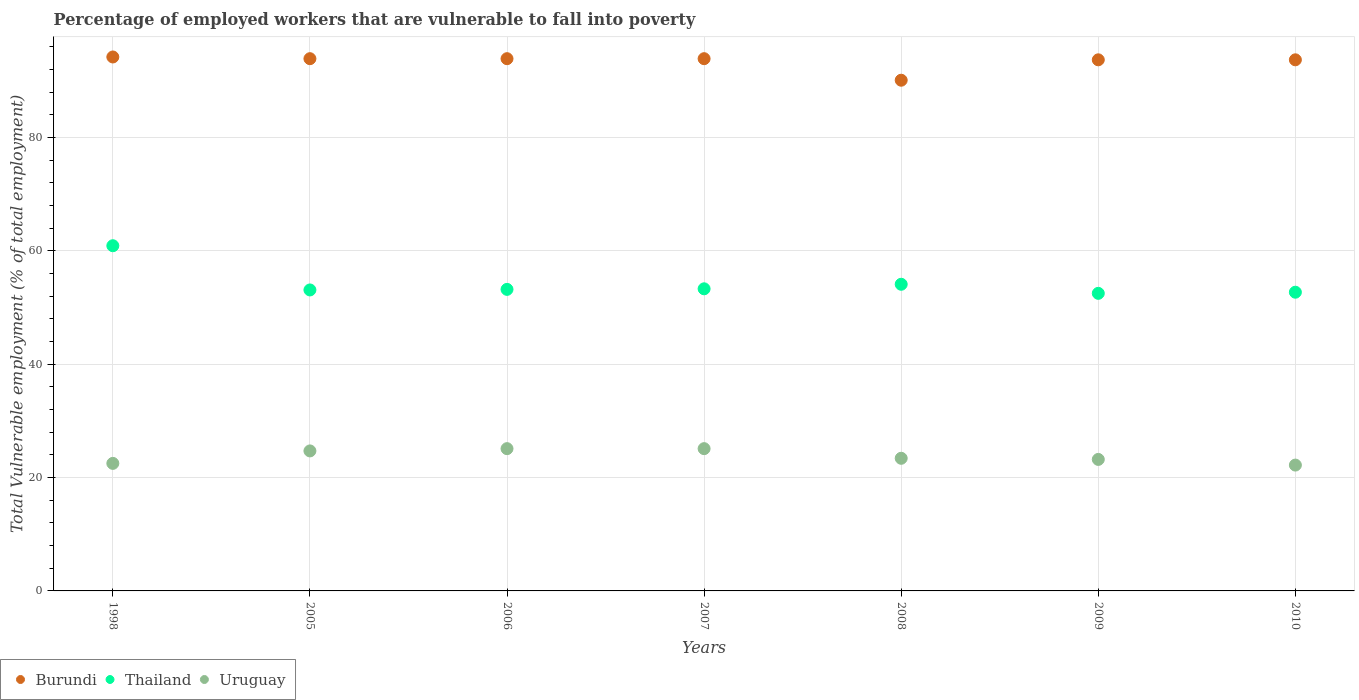Is the number of dotlines equal to the number of legend labels?
Provide a short and direct response. Yes. What is the percentage of employed workers who are vulnerable to fall into poverty in Thailand in 1998?
Your response must be concise. 60.9. Across all years, what is the maximum percentage of employed workers who are vulnerable to fall into poverty in Burundi?
Your answer should be very brief. 94.2. Across all years, what is the minimum percentage of employed workers who are vulnerable to fall into poverty in Burundi?
Offer a very short reply. 90.1. In which year was the percentage of employed workers who are vulnerable to fall into poverty in Uruguay minimum?
Offer a terse response. 2010. What is the total percentage of employed workers who are vulnerable to fall into poverty in Burundi in the graph?
Your answer should be very brief. 653.4. What is the difference between the percentage of employed workers who are vulnerable to fall into poverty in Burundi in 2007 and that in 2010?
Your answer should be compact. 0.2. What is the difference between the percentage of employed workers who are vulnerable to fall into poverty in Burundi in 2008 and the percentage of employed workers who are vulnerable to fall into poverty in Uruguay in 2010?
Give a very brief answer. 67.9. What is the average percentage of employed workers who are vulnerable to fall into poverty in Thailand per year?
Ensure brevity in your answer.  54.26. In the year 2005, what is the difference between the percentage of employed workers who are vulnerable to fall into poverty in Burundi and percentage of employed workers who are vulnerable to fall into poverty in Uruguay?
Give a very brief answer. 69.2. What is the ratio of the percentage of employed workers who are vulnerable to fall into poverty in Uruguay in 2005 to that in 2009?
Ensure brevity in your answer.  1.06. Is the difference between the percentage of employed workers who are vulnerable to fall into poverty in Burundi in 2006 and 2009 greater than the difference between the percentage of employed workers who are vulnerable to fall into poverty in Uruguay in 2006 and 2009?
Your answer should be very brief. No. What is the difference between the highest and the second highest percentage of employed workers who are vulnerable to fall into poverty in Burundi?
Your answer should be compact. 0.3. What is the difference between the highest and the lowest percentage of employed workers who are vulnerable to fall into poverty in Thailand?
Ensure brevity in your answer.  8.4. Does the percentage of employed workers who are vulnerable to fall into poverty in Uruguay monotonically increase over the years?
Provide a short and direct response. No. Is the percentage of employed workers who are vulnerable to fall into poverty in Uruguay strictly less than the percentage of employed workers who are vulnerable to fall into poverty in Burundi over the years?
Your answer should be very brief. Yes. How many dotlines are there?
Make the answer very short. 3. How many years are there in the graph?
Give a very brief answer. 7. What is the difference between two consecutive major ticks on the Y-axis?
Keep it short and to the point. 20. Does the graph contain any zero values?
Offer a terse response. No. Does the graph contain grids?
Make the answer very short. Yes. What is the title of the graph?
Give a very brief answer. Percentage of employed workers that are vulnerable to fall into poverty. Does "France" appear as one of the legend labels in the graph?
Offer a terse response. No. What is the label or title of the X-axis?
Make the answer very short. Years. What is the label or title of the Y-axis?
Make the answer very short. Total Vulnerable employment (% of total employment). What is the Total Vulnerable employment (% of total employment) in Burundi in 1998?
Give a very brief answer. 94.2. What is the Total Vulnerable employment (% of total employment) in Thailand in 1998?
Provide a short and direct response. 60.9. What is the Total Vulnerable employment (% of total employment) of Uruguay in 1998?
Make the answer very short. 22.5. What is the Total Vulnerable employment (% of total employment) in Burundi in 2005?
Provide a succinct answer. 93.9. What is the Total Vulnerable employment (% of total employment) in Thailand in 2005?
Provide a short and direct response. 53.1. What is the Total Vulnerable employment (% of total employment) in Uruguay in 2005?
Ensure brevity in your answer.  24.7. What is the Total Vulnerable employment (% of total employment) of Burundi in 2006?
Your answer should be compact. 93.9. What is the Total Vulnerable employment (% of total employment) of Thailand in 2006?
Provide a succinct answer. 53.2. What is the Total Vulnerable employment (% of total employment) in Uruguay in 2006?
Keep it short and to the point. 25.1. What is the Total Vulnerable employment (% of total employment) of Burundi in 2007?
Your response must be concise. 93.9. What is the Total Vulnerable employment (% of total employment) in Thailand in 2007?
Provide a short and direct response. 53.3. What is the Total Vulnerable employment (% of total employment) of Uruguay in 2007?
Make the answer very short. 25.1. What is the Total Vulnerable employment (% of total employment) in Burundi in 2008?
Provide a succinct answer. 90.1. What is the Total Vulnerable employment (% of total employment) of Thailand in 2008?
Keep it short and to the point. 54.1. What is the Total Vulnerable employment (% of total employment) in Uruguay in 2008?
Give a very brief answer. 23.4. What is the Total Vulnerable employment (% of total employment) in Burundi in 2009?
Your answer should be compact. 93.7. What is the Total Vulnerable employment (% of total employment) of Thailand in 2009?
Your answer should be very brief. 52.5. What is the Total Vulnerable employment (% of total employment) of Uruguay in 2009?
Your answer should be very brief. 23.2. What is the Total Vulnerable employment (% of total employment) of Burundi in 2010?
Your response must be concise. 93.7. What is the Total Vulnerable employment (% of total employment) in Thailand in 2010?
Your response must be concise. 52.7. What is the Total Vulnerable employment (% of total employment) in Uruguay in 2010?
Offer a terse response. 22.2. Across all years, what is the maximum Total Vulnerable employment (% of total employment) in Burundi?
Give a very brief answer. 94.2. Across all years, what is the maximum Total Vulnerable employment (% of total employment) of Thailand?
Make the answer very short. 60.9. Across all years, what is the maximum Total Vulnerable employment (% of total employment) of Uruguay?
Your response must be concise. 25.1. Across all years, what is the minimum Total Vulnerable employment (% of total employment) in Burundi?
Provide a short and direct response. 90.1. Across all years, what is the minimum Total Vulnerable employment (% of total employment) in Thailand?
Make the answer very short. 52.5. Across all years, what is the minimum Total Vulnerable employment (% of total employment) in Uruguay?
Make the answer very short. 22.2. What is the total Total Vulnerable employment (% of total employment) in Burundi in the graph?
Ensure brevity in your answer.  653.4. What is the total Total Vulnerable employment (% of total employment) in Thailand in the graph?
Your answer should be compact. 379.8. What is the total Total Vulnerable employment (% of total employment) of Uruguay in the graph?
Offer a terse response. 166.2. What is the difference between the Total Vulnerable employment (% of total employment) of Burundi in 1998 and that in 2005?
Give a very brief answer. 0.3. What is the difference between the Total Vulnerable employment (% of total employment) of Thailand in 1998 and that in 2005?
Provide a succinct answer. 7.8. What is the difference between the Total Vulnerable employment (% of total employment) in Thailand in 1998 and that in 2006?
Your response must be concise. 7.7. What is the difference between the Total Vulnerable employment (% of total employment) of Burundi in 1998 and that in 2007?
Make the answer very short. 0.3. What is the difference between the Total Vulnerable employment (% of total employment) of Thailand in 1998 and that in 2007?
Give a very brief answer. 7.6. What is the difference between the Total Vulnerable employment (% of total employment) in Uruguay in 1998 and that in 2007?
Provide a succinct answer. -2.6. What is the difference between the Total Vulnerable employment (% of total employment) of Uruguay in 1998 and that in 2008?
Offer a very short reply. -0.9. What is the difference between the Total Vulnerable employment (% of total employment) in Burundi in 1998 and that in 2009?
Your response must be concise. 0.5. What is the difference between the Total Vulnerable employment (% of total employment) in Thailand in 1998 and that in 2009?
Provide a succinct answer. 8.4. What is the difference between the Total Vulnerable employment (% of total employment) of Burundi in 1998 and that in 2010?
Keep it short and to the point. 0.5. What is the difference between the Total Vulnerable employment (% of total employment) in Burundi in 2005 and that in 2006?
Give a very brief answer. 0. What is the difference between the Total Vulnerable employment (% of total employment) of Thailand in 2005 and that in 2006?
Keep it short and to the point. -0.1. What is the difference between the Total Vulnerable employment (% of total employment) of Thailand in 2005 and that in 2007?
Offer a terse response. -0.2. What is the difference between the Total Vulnerable employment (% of total employment) in Thailand in 2005 and that in 2008?
Your response must be concise. -1. What is the difference between the Total Vulnerable employment (% of total employment) of Burundi in 2005 and that in 2009?
Ensure brevity in your answer.  0.2. What is the difference between the Total Vulnerable employment (% of total employment) of Uruguay in 2005 and that in 2009?
Provide a succinct answer. 1.5. What is the difference between the Total Vulnerable employment (% of total employment) of Uruguay in 2005 and that in 2010?
Provide a short and direct response. 2.5. What is the difference between the Total Vulnerable employment (% of total employment) of Burundi in 2006 and that in 2007?
Your answer should be very brief. 0. What is the difference between the Total Vulnerable employment (% of total employment) in Thailand in 2006 and that in 2007?
Your response must be concise. -0.1. What is the difference between the Total Vulnerable employment (% of total employment) in Uruguay in 2006 and that in 2007?
Provide a short and direct response. 0. What is the difference between the Total Vulnerable employment (% of total employment) in Burundi in 2006 and that in 2008?
Offer a very short reply. 3.8. What is the difference between the Total Vulnerable employment (% of total employment) of Burundi in 2006 and that in 2009?
Give a very brief answer. 0.2. What is the difference between the Total Vulnerable employment (% of total employment) of Burundi in 2006 and that in 2010?
Offer a very short reply. 0.2. What is the difference between the Total Vulnerable employment (% of total employment) of Thailand in 2006 and that in 2010?
Your response must be concise. 0.5. What is the difference between the Total Vulnerable employment (% of total employment) of Thailand in 2007 and that in 2008?
Make the answer very short. -0.8. What is the difference between the Total Vulnerable employment (% of total employment) in Uruguay in 2007 and that in 2008?
Your answer should be compact. 1.7. What is the difference between the Total Vulnerable employment (% of total employment) in Burundi in 2007 and that in 2009?
Your response must be concise. 0.2. What is the difference between the Total Vulnerable employment (% of total employment) of Uruguay in 2007 and that in 2009?
Your response must be concise. 1.9. What is the difference between the Total Vulnerable employment (% of total employment) in Burundi in 2007 and that in 2010?
Your answer should be compact. 0.2. What is the difference between the Total Vulnerable employment (% of total employment) of Uruguay in 2007 and that in 2010?
Offer a terse response. 2.9. What is the difference between the Total Vulnerable employment (% of total employment) in Burundi in 2008 and that in 2009?
Your response must be concise. -3.6. What is the difference between the Total Vulnerable employment (% of total employment) in Uruguay in 2008 and that in 2009?
Your response must be concise. 0.2. What is the difference between the Total Vulnerable employment (% of total employment) of Burundi in 2008 and that in 2010?
Keep it short and to the point. -3.6. What is the difference between the Total Vulnerable employment (% of total employment) of Thailand in 2009 and that in 2010?
Your answer should be very brief. -0.2. What is the difference between the Total Vulnerable employment (% of total employment) in Burundi in 1998 and the Total Vulnerable employment (% of total employment) in Thailand in 2005?
Provide a succinct answer. 41.1. What is the difference between the Total Vulnerable employment (% of total employment) of Burundi in 1998 and the Total Vulnerable employment (% of total employment) of Uruguay in 2005?
Your response must be concise. 69.5. What is the difference between the Total Vulnerable employment (% of total employment) in Thailand in 1998 and the Total Vulnerable employment (% of total employment) in Uruguay in 2005?
Keep it short and to the point. 36.2. What is the difference between the Total Vulnerable employment (% of total employment) in Burundi in 1998 and the Total Vulnerable employment (% of total employment) in Uruguay in 2006?
Make the answer very short. 69.1. What is the difference between the Total Vulnerable employment (% of total employment) of Thailand in 1998 and the Total Vulnerable employment (% of total employment) of Uruguay in 2006?
Your response must be concise. 35.8. What is the difference between the Total Vulnerable employment (% of total employment) in Burundi in 1998 and the Total Vulnerable employment (% of total employment) in Thailand in 2007?
Provide a short and direct response. 40.9. What is the difference between the Total Vulnerable employment (% of total employment) of Burundi in 1998 and the Total Vulnerable employment (% of total employment) of Uruguay in 2007?
Ensure brevity in your answer.  69.1. What is the difference between the Total Vulnerable employment (% of total employment) in Thailand in 1998 and the Total Vulnerable employment (% of total employment) in Uruguay in 2007?
Make the answer very short. 35.8. What is the difference between the Total Vulnerable employment (% of total employment) in Burundi in 1998 and the Total Vulnerable employment (% of total employment) in Thailand in 2008?
Provide a short and direct response. 40.1. What is the difference between the Total Vulnerable employment (% of total employment) in Burundi in 1998 and the Total Vulnerable employment (% of total employment) in Uruguay in 2008?
Keep it short and to the point. 70.8. What is the difference between the Total Vulnerable employment (% of total employment) of Thailand in 1998 and the Total Vulnerable employment (% of total employment) of Uruguay in 2008?
Give a very brief answer. 37.5. What is the difference between the Total Vulnerable employment (% of total employment) of Burundi in 1998 and the Total Vulnerable employment (% of total employment) of Thailand in 2009?
Give a very brief answer. 41.7. What is the difference between the Total Vulnerable employment (% of total employment) of Burundi in 1998 and the Total Vulnerable employment (% of total employment) of Uruguay in 2009?
Make the answer very short. 71. What is the difference between the Total Vulnerable employment (% of total employment) in Thailand in 1998 and the Total Vulnerable employment (% of total employment) in Uruguay in 2009?
Your answer should be very brief. 37.7. What is the difference between the Total Vulnerable employment (% of total employment) of Burundi in 1998 and the Total Vulnerable employment (% of total employment) of Thailand in 2010?
Your answer should be very brief. 41.5. What is the difference between the Total Vulnerable employment (% of total employment) in Thailand in 1998 and the Total Vulnerable employment (% of total employment) in Uruguay in 2010?
Your answer should be compact. 38.7. What is the difference between the Total Vulnerable employment (% of total employment) in Burundi in 2005 and the Total Vulnerable employment (% of total employment) in Thailand in 2006?
Give a very brief answer. 40.7. What is the difference between the Total Vulnerable employment (% of total employment) in Burundi in 2005 and the Total Vulnerable employment (% of total employment) in Uruguay in 2006?
Your response must be concise. 68.8. What is the difference between the Total Vulnerable employment (% of total employment) in Thailand in 2005 and the Total Vulnerable employment (% of total employment) in Uruguay in 2006?
Ensure brevity in your answer.  28. What is the difference between the Total Vulnerable employment (% of total employment) in Burundi in 2005 and the Total Vulnerable employment (% of total employment) in Thailand in 2007?
Provide a short and direct response. 40.6. What is the difference between the Total Vulnerable employment (% of total employment) in Burundi in 2005 and the Total Vulnerable employment (% of total employment) in Uruguay in 2007?
Provide a short and direct response. 68.8. What is the difference between the Total Vulnerable employment (% of total employment) of Burundi in 2005 and the Total Vulnerable employment (% of total employment) of Thailand in 2008?
Your answer should be compact. 39.8. What is the difference between the Total Vulnerable employment (% of total employment) of Burundi in 2005 and the Total Vulnerable employment (% of total employment) of Uruguay in 2008?
Provide a succinct answer. 70.5. What is the difference between the Total Vulnerable employment (% of total employment) of Thailand in 2005 and the Total Vulnerable employment (% of total employment) of Uruguay in 2008?
Your answer should be very brief. 29.7. What is the difference between the Total Vulnerable employment (% of total employment) of Burundi in 2005 and the Total Vulnerable employment (% of total employment) of Thailand in 2009?
Your answer should be compact. 41.4. What is the difference between the Total Vulnerable employment (% of total employment) in Burundi in 2005 and the Total Vulnerable employment (% of total employment) in Uruguay in 2009?
Make the answer very short. 70.7. What is the difference between the Total Vulnerable employment (% of total employment) in Thailand in 2005 and the Total Vulnerable employment (% of total employment) in Uruguay in 2009?
Provide a short and direct response. 29.9. What is the difference between the Total Vulnerable employment (% of total employment) of Burundi in 2005 and the Total Vulnerable employment (% of total employment) of Thailand in 2010?
Give a very brief answer. 41.2. What is the difference between the Total Vulnerable employment (% of total employment) of Burundi in 2005 and the Total Vulnerable employment (% of total employment) of Uruguay in 2010?
Offer a very short reply. 71.7. What is the difference between the Total Vulnerable employment (% of total employment) in Thailand in 2005 and the Total Vulnerable employment (% of total employment) in Uruguay in 2010?
Provide a short and direct response. 30.9. What is the difference between the Total Vulnerable employment (% of total employment) of Burundi in 2006 and the Total Vulnerable employment (% of total employment) of Thailand in 2007?
Make the answer very short. 40.6. What is the difference between the Total Vulnerable employment (% of total employment) of Burundi in 2006 and the Total Vulnerable employment (% of total employment) of Uruguay in 2007?
Offer a terse response. 68.8. What is the difference between the Total Vulnerable employment (% of total employment) in Thailand in 2006 and the Total Vulnerable employment (% of total employment) in Uruguay in 2007?
Your answer should be very brief. 28.1. What is the difference between the Total Vulnerable employment (% of total employment) of Burundi in 2006 and the Total Vulnerable employment (% of total employment) of Thailand in 2008?
Your answer should be compact. 39.8. What is the difference between the Total Vulnerable employment (% of total employment) of Burundi in 2006 and the Total Vulnerable employment (% of total employment) of Uruguay in 2008?
Your response must be concise. 70.5. What is the difference between the Total Vulnerable employment (% of total employment) in Thailand in 2006 and the Total Vulnerable employment (% of total employment) in Uruguay in 2008?
Give a very brief answer. 29.8. What is the difference between the Total Vulnerable employment (% of total employment) of Burundi in 2006 and the Total Vulnerable employment (% of total employment) of Thailand in 2009?
Offer a very short reply. 41.4. What is the difference between the Total Vulnerable employment (% of total employment) in Burundi in 2006 and the Total Vulnerable employment (% of total employment) in Uruguay in 2009?
Your response must be concise. 70.7. What is the difference between the Total Vulnerable employment (% of total employment) in Thailand in 2006 and the Total Vulnerable employment (% of total employment) in Uruguay in 2009?
Your answer should be compact. 30. What is the difference between the Total Vulnerable employment (% of total employment) of Burundi in 2006 and the Total Vulnerable employment (% of total employment) of Thailand in 2010?
Provide a succinct answer. 41.2. What is the difference between the Total Vulnerable employment (% of total employment) of Burundi in 2006 and the Total Vulnerable employment (% of total employment) of Uruguay in 2010?
Your answer should be compact. 71.7. What is the difference between the Total Vulnerable employment (% of total employment) of Thailand in 2006 and the Total Vulnerable employment (% of total employment) of Uruguay in 2010?
Ensure brevity in your answer.  31. What is the difference between the Total Vulnerable employment (% of total employment) in Burundi in 2007 and the Total Vulnerable employment (% of total employment) in Thailand in 2008?
Give a very brief answer. 39.8. What is the difference between the Total Vulnerable employment (% of total employment) of Burundi in 2007 and the Total Vulnerable employment (% of total employment) of Uruguay in 2008?
Your answer should be very brief. 70.5. What is the difference between the Total Vulnerable employment (% of total employment) in Thailand in 2007 and the Total Vulnerable employment (% of total employment) in Uruguay in 2008?
Provide a succinct answer. 29.9. What is the difference between the Total Vulnerable employment (% of total employment) of Burundi in 2007 and the Total Vulnerable employment (% of total employment) of Thailand in 2009?
Provide a succinct answer. 41.4. What is the difference between the Total Vulnerable employment (% of total employment) of Burundi in 2007 and the Total Vulnerable employment (% of total employment) of Uruguay in 2009?
Offer a very short reply. 70.7. What is the difference between the Total Vulnerable employment (% of total employment) in Thailand in 2007 and the Total Vulnerable employment (% of total employment) in Uruguay in 2009?
Provide a short and direct response. 30.1. What is the difference between the Total Vulnerable employment (% of total employment) in Burundi in 2007 and the Total Vulnerable employment (% of total employment) in Thailand in 2010?
Ensure brevity in your answer.  41.2. What is the difference between the Total Vulnerable employment (% of total employment) of Burundi in 2007 and the Total Vulnerable employment (% of total employment) of Uruguay in 2010?
Provide a succinct answer. 71.7. What is the difference between the Total Vulnerable employment (% of total employment) in Thailand in 2007 and the Total Vulnerable employment (% of total employment) in Uruguay in 2010?
Keep it short and to the point. 31.1. What is the difference between the Total Vulnerable employment (% of total employment) in Burundi in 2008 and the Total Vulnerable employment (% of total employment) in Thailand in 2009?
Make the answer very short. 37.6. What is the difference between the Total Vulnerable employment (% of total employment) in Burundi in 2008 and the Total Vulnerable employment (% of total employment) in Uruguay in 2009?
Offer a terse response. 66.9. What is the difference between the Total Vulnerable employment (% of total employment) in Thailand in 2008 and the Total Vulnerable employment (% of total employment) in Uruguay in 2009?
Keep it short and to the point. 30.9. What is the difference between the Total Vulnerable employment (% of total employment) of Burundi in 2008 and the Total Vulnerable employment (% of total employment) of Thailand in 2010?
Your response must be concise. 37.4. What is the difference between the Total Vulnerable employment (% of total employment) in Burundi in 2008 and the Total Vulnerable employment (% of total employment) in Uruguay in 2010?
Your answer should be very brief. 67.9. What is the difference between the Total Vulnerable employment (% of total employment) in Thailand in 2008 and the Total Vulnerable employment (% of total employment) in Uruguay in 2010?
Provide a short and direct response. 31.9. What is the difference between the Total Vulnerable employment (% of total employment) of Burundi in 2009 and the Total Vulnerable employment (% of total employment) of Uruguay in 2010?
Keep it short and to the point. 71.5. What is the difference between the Total Vulnerable employment (% of total employment) of Thailand in 2009 and the Total Vulnerable employment (% of total employment) of Uruguay in 2010?
Keep it short and to the point. 30.3. What is the average Total Vulnerable employment (% of total employment) in Burundi per year?
Give a very brief answer. 93.34. What is the average Total Vulnerable employment (% of total employment) in Thailand per year?
Offer a terse response. 54.26. What is the average Total Vulnerable employment (% of total employment) of Uruguay per year?
Offer a terse response. 23.74. In the year 1998, what is the difference between the Total Vulnerable employment (% of total employment) of Burundi and Total Vulnerable employment (% of total employment) of Thailand?
Keep it short and to the point. 33.3. In the year 1998, what is the difference between the Total Vulnerable employment (% of total employment) of Burundi and Total Vulnerable employment (% of total employment) of Uruguay?
Your answer should be compact. 71.7. In the year 1998, what is the difference between the Total Vulnerable employment (% of total employment) of Thailand and Total Vulnerable employment (% of total employment) of Uruguay?
Provide a short and direct response. 38.4. In the year 2005, what is the difference between the Total Vulnerable employment (% of total employment) in Burundi and Total Vulnerable employment (% of total employment) in Thailand?
Your answer should be compact. 40.8. In the year 2005, what is the difference between the Total Vulnerable employment (% of total employment) of Burundi and Total Vulnerable employment (% of total employment) of Uruguay?
Provide a short and direct response. 69.2. In the year 2005, what is the difference between the Total Vulnerable employment (% of total employment) of Thailand and Total Vulnerable employment (% of total employment) of Uruguay?
Keep it short and to the point. 28.4. In the year 2006, what is the difference between the Total Vulnerable employment (% of total employment) of Burundi and Total Vulnerable employment (% of total employment) of Thailand?
Ensure brevity in your answer.  40.7. In the year 2006, what is the difference between the Total Vulnerable employment (% of total employment) in Burundi and Total Vulnerable employment (% of total employment) in Uruguay?
Ensure brevity in your answer.  68.8. In the year 2006, what is the difference between the Total Vulnerable employment (% of total employment) in Thailand and Total Vulnerable employment (% of total employment) in Uruguay?
Offer a very short reply. 28.1. In the year 2007, what is the difference between the Total Vulnerable employment (% of total employment) in Burundi and Total Vulnerable employment (% of total employment) in Thailand?
Your response must be concise. 40.6. In the year 2007, what is the difference between the Total Vulnerable employment (% of total employment) in Burundi and Total Vulnerable employment (% of total employment) in Uruguay?
Ensure brevity in your answer.  68.8. In the year 2007, what is the difference between the Total Vulnerable employment (% of total employment) of Thailand and Total Vulnerable employment (% of total employment) of Uruguay?
Offer a very short reply. 28.2. In the year 2008, what is the difference between the Total Vulnerable employment (% of total employment) in Burundi and Total Vulnerable employment (% of total employment) in Thailand?
Your answer should be very brief. 36. In the year 2008, what is the difference between the Total Vulnerable employment (% of total employment) of Burundi and Total Vulnerable employment (% of total employment) of Uruguay?
Your response must be concise. 66.7. In the year 2008, what is the difference between the Total Vulnerable employment (% of total employment) in Thailand and Total Vulnerable employment (% of total employment) in Uruguay?
Provide a short and direct response. 30.7. In the year 2009, what is the difference between the Total Vulnerable employment (% of total employment) of Burundi and Total Vulnerable employment (% of total employment) of Thailand?
Your answer should be compact. 41.2. In the year 2009, what is the difference between the Total Vulnerable employment (% of total employment) in Burundi and Total Vulnerable employment (% of total employment) in Uruguay?
Your answer should be compact. 70.5. In the year 2009, what is the difference between the Total Vulnerable employment (% of total employment) in Thailand and Total Vulnerable employment (% of total employment) in Uruguay?
Provide a succinct answer. 29.3. In the year 2010, what is the difference between the Total Vulnerable employment (% of total employment) in Burundi and Total Vulnerable employment (% of total employment) in Uruguay?
Offer a terse response. 71.5. In the year 2010, what is the difference between the Total Vulnerable employment (% of total employment) in Thailand and Total Vulnerable employment (% of total employment) in Uruguay?
Make the answer very short. 30.5. What is the ratio of the Total Vulnerable employment (% of total employment) of Burundi in 1998 to that in 2005?
Your response must be concise. 1. What is the ratio of the Total Vulnerable employment (% of total employment) of Thailand in 1998 to that in 2005?
Ensure brevity in your answer.  1.15. What is the ratio of the Total Vulnerable employment (% of total employment) in Uruguay in 1998 to that in 2005?
Your response must be concise. 0.91. What is the ratio of the Total Vulnerable employment (% of total employment) in Burundi in 1998 to that in 2006?
Ensure brevity in your answer.  1. What is the ratio of the Total Vulnerable employment (% of total employment) of Thailand in 1998 to that in 2006?
Your answer should be compact. 1.14. What is the ratio of the Total Vulnerable employment (% of total employment) in Uruguay in 1998 to that in 2006?
Your response must be concise. 0.9. What is the ratio of the Total Vulnerable employment (% of total employment) in Thailand in 1998 to that in 2007?
Make the answer very short. 1.14. What is the ratio of the Total Vulnerable employment (% of total employment) of Uruguay in 1998 to that in 2007?
Your response must be concise. 0.9. What is the ratio of the Total Vulnerable employment (% of total employment) of Burundi in 1998 to that in 2008?
Provide a short and direct response. 1.05. What is the ratio of the Total Vulnerable employment (% of total employment) in Thailand in 1998 to that in 2008?
Offer a very short reply. 1.13. What is the ratio of the Total Vulnerable employment (% of total employment) in Uruguay in 1998 to that in 2008?
Make the answer very short. 0.96. What is the ratio of the Total Vulnerable employment (% of total employment) in Thailand in 1998 to that in 2009?
Your answer should be very brief. 1.16. What is the ratio of the Total Vulnerable employment (% of total employment) in Uruguay in 1998 to that in 2009?
Provide a succinct answer. 0.97. What is the ratio of the Total Vulnerable employment (% of total employment) of Thailand in 1998 to that in 2010?
Provide a short and direct response. 1.16. What is the ratio of the Total Vulnerable employment (% of total employment) of Uruguay in 1998 to that in 2010?
Offer a terse response. 1.01. What is the ratio of the Total Vulnerable employment (% of total employment) of Uruguay in 2005 to that in 2006?
Keep it short and to the point. 0.98. What is the ratio of the Total Vulnerable employment (% of total employment) in Uruguay in 2005 to that in 2007?
Keep it short and to the point. 0.98. What is the ratio of the Total Vulnerable employment (% of total employment) of Burundi in 2005 to that in 2008?
Your response must be concise. 1.04. What is the ratio of the Total Vulnerable employment (% of total employment) of Thailand in 2005 to that in 2008?
Provide a succinct answer. 0.98. What is the ratio of the Total Vulnerable employment (% of total employment) in Uruguay in 2005 to that in 2008?
Provide a short and direct response. 1.06. What is the ratio of the Total Vulnerable employment (% of total employment) of Thailand in 2005 to that in 2009?
Ensure brevity in your answer.  1.01. What is the ratio of the Total Vulnerable employment (% of total employment) in Uruguay in 2005 to that in 2009?
Give a very brief answer. 1.06. What is the ratio of the Total Vulnerable employment (% of total employment) in Thailand in 2005 to that in 2010?
Provide a succinct answer. 1.01. What is the ratio of the Total Vulnerable employment (% of total employment) in Uruguay in 2005 to that in 2010?
Make the answer very short. 1.11. What is the ratio of the Total Vulnerable employment (% of total employment) in Burundi in 2006 to that in 2007?
Provide a short and direct response. 1. What is the ratio of the Total Vulnerable employment (% of total employment) in Uruguay in 2006 to that in 2007?
Make the answer very short. 1. What is the ratio of the Total Vulnerable employment (% of total employment) of Burundi in 2006 to that in 2008?
Your answer should be compact. 1.04. What is the ratio of the Total Vulnerable employment (% of total employment) in Thailand in 2006 to that in 2008?
Your response must be concise. 0.98. What is the ratio of the Total Vulnerable employment (% of total employment) of Uruguay in 2006 to that in 2008?
Make the answer very short. 1.07. What is the ratio of the Total Vulnerable employment (% of total employment) in Burundi in 2006 to that in 2009?
Your response must be concise. 1. What is the ratio of the Total Vulnerable employment (% of total employment) of Thailand in 2006 to that in 2009?
Your answer should be very brief. 1.01. What is the ratio of the Total Vulnerable employment (% of total employment) of Uruguay in 2006 to that in 2009?
Ensure brevity in your answer.  1.08. What is the ratio of the Total Vulnerable employment (% of total employment) of Burundi in 2006 to that in 2010?
Make the answer very short. 1. What is the ratio of the Total Vulnerable employment (% of total employment) in Thailand in 2006 to that in 2010?
Provide a succinct answer. 1.01. What is the ratio of the Total Vulnerable employment (% of total employment) of Uruguay in 2006 to that in 2010?
Give a very brief answer. 1.13. What is the ratio of the Total Vulnerable employment (% of total employment) in Burundi in 2007 to that in 2008?
Give a very brief answer. 1.04. What is the ratio of the Total Vulnerable employment (% of total employment) in Thailand in 2007 to that in 2008?
Ensure brevity in your answer.  0.99. What is the ratio of the Total Vulnerable employment (% of total employment) of Uruguay in 2007 to that in 2008?
Provide a short and direct response. 1.07. What is the ratio of the Total Vulnerable employment (% of total employment) in Thailand in 2007 to that in 2009?
Provide a short and direct response. 1.02. What is the ratio of the Total Vulnerable employment (% of total employment) in Uruguay in 2007 to that in 2009?
Make the answer very short. 1.08. What is the ratio of the Total Vulnerable employment (% of total employment) in Thailand in 2007 to that in 2010?
Make the answer very short. 1.01. What is the ratio of the Total Vulnerable employment (% of total employment) of Uruguay in 2007 to that in 2010?
Make the answer very short. 1.13. What is the ratio of the Total Vulnerable employment (% of total employment) of Burundi in 2008 to that in 2009?
Your response must be concise. 0.96. What is the ratio of the Total Vulnerable employment (% of total employment) in Thailand in 2008 to that in 2009?
Provide a succinct answer. 1.03. What is the ratio of the Total Vulnerable employment (% of total employment) in Uruguay in 2008 to that in 2009?
Give a very brief answer. 1.01. What is the ratio of the Total Vulnerable employment (% of total employment) of Burundi in 2008 to that in 2010?
Provide a succinct answer. 0.96. What is the ratio of the Total Vulnerable employment (% of total employment) in Thailand in 2008 to that in 2010?
Provide a short and direct response. 1.03. What is the ratio of the Total Vulnerable employment (% of total employment) in Uruguay in 2008 to that in 2010?
Your response must be concise. 1.05. What is the ratio of the Total Vulnerable employment (% of total employment) in Burundi in 2009 to that in 2010?
Give a very brief answer. 1. What is the ratio of the Total Vulnerable employment (% of total employment) of Uruguay in 2009 to that in 2010?
Your answer should be very brief. 1.04. What is the difference between the highest and the second highest Total Vulnerable employment (% of total employment) of Burundi?
Make the answer very short. 0.3. What is the difference between the highest and the lowest Total Vulnerable employment (% of total employment) of Thailand?
Make the answer very short. 8.4. What is the difference between the highest and the lowest Total Vulnerable employment (% of total employment) of Uruguay?
Provide a succinct answer. 2.9. 